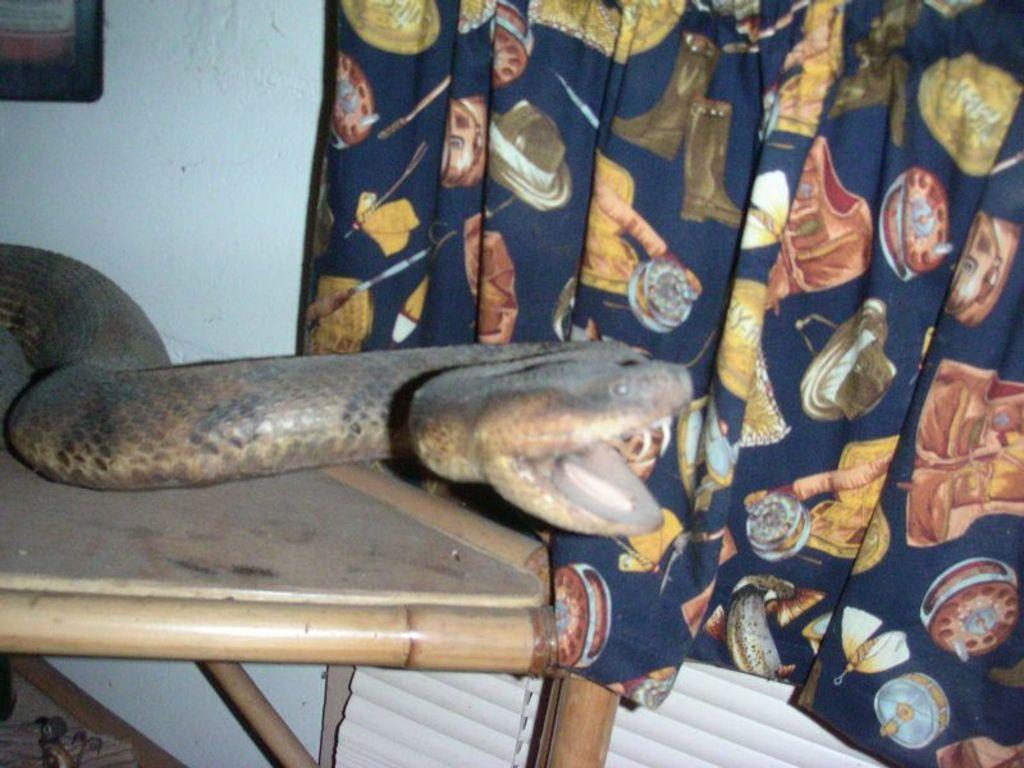Could you give a brief overview of what you see in this image? In the image we can see the snake, wooden table, wall, curtains and a floor. 